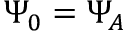<formula> <loc_0><loc_0><loc_500><loc_500>\Psi _ { 0 } = \Psi _ { A }</formula> 